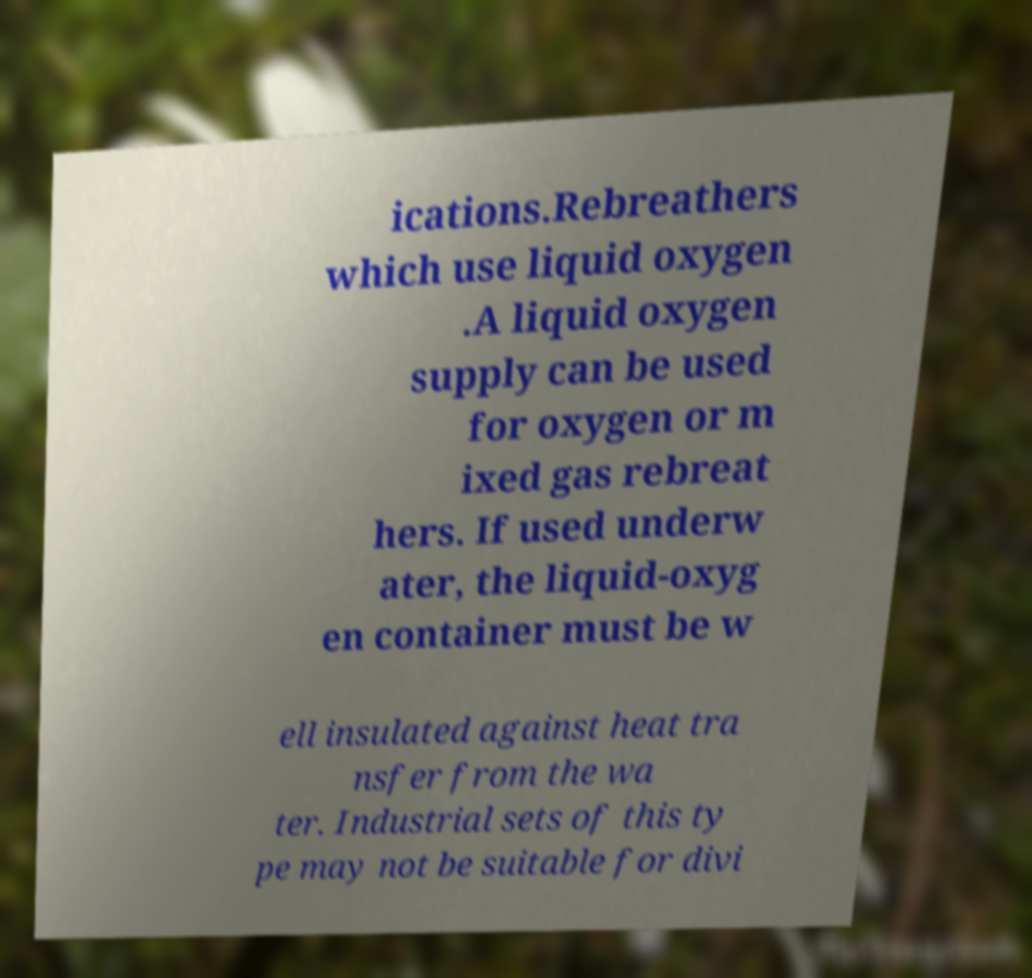What messages or text are displayed in this image? I need them in a readable, typed format. ications.Rebreathers which use liquid oxygen .A liquid oxygen supply can be used for oxygen or m ixed gas rebreat hers. If used underw ater, the liquid-oxyg en container must be w ell insulated against heat tra nsfer from the wa ter. Industrial sets of this ty pe may not be suitable for divi 